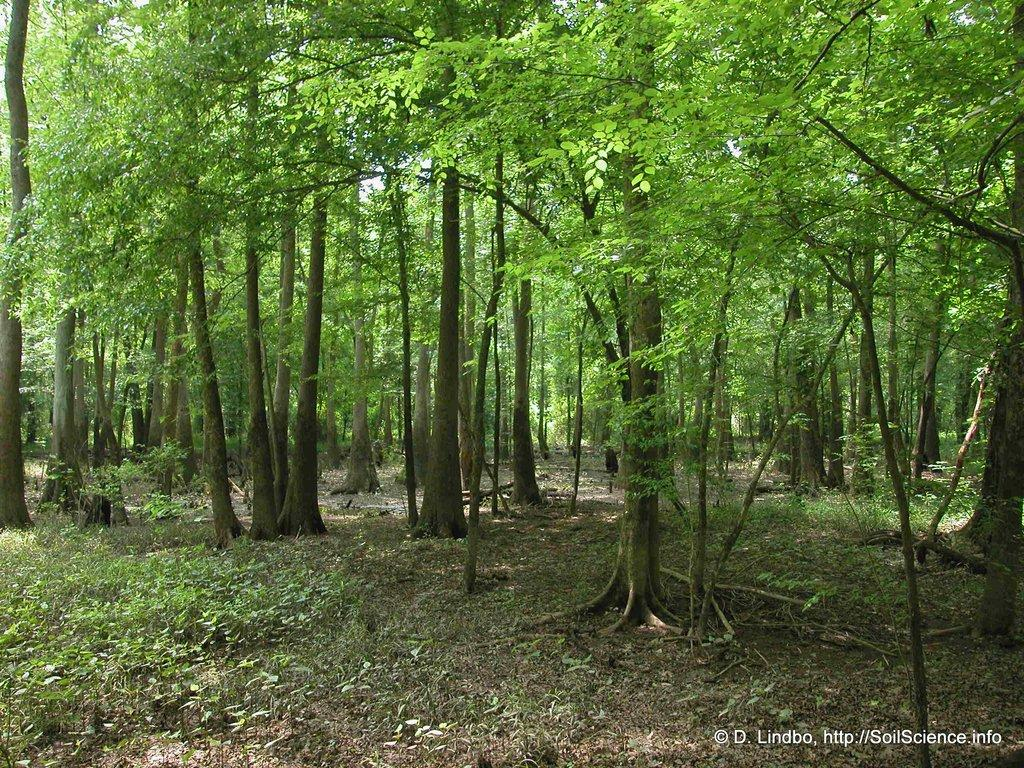What type of vegetation can be seen in the image? There are trees and plants in the image. Can you describe the text at the bottom right corner of the image? Unfortunately, the specific content of the text cannot be determined from the provided facts. What is the primary focus of the image? Based on the facts provided, the primary focus of the image appears to be the trees and plants. How many quince are hanging from the trees in the image? There is no mention of quince in the provided facts, and therefore we cannot determine if any are present in the image. What is the purpose of the cars in the image? There are no cars present in the image, so we cannot determine their purpose. 